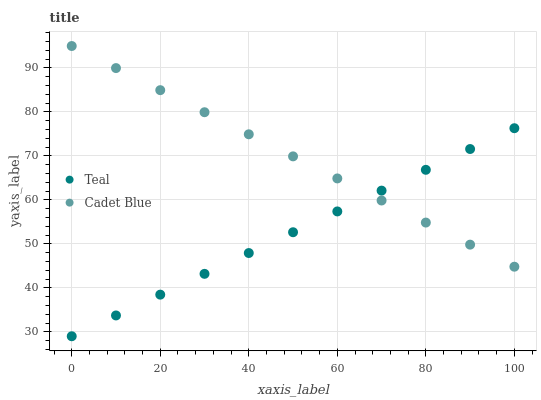Does Teal have the minimum area under the curve?
Answer yes or no. Yes. Does Cadet Blue have the maximum area under the curve?
Answer yes or no. Yes. Does Teal have the maximum area under the curve?
Answer yes or no. No. Is Teal the smoothest?
Answer yes or no. Yes. Is Cadet Blue the roughest?
Answer yes or no. Yes. Is Teal the roughest?
Answer yes or no. No. Does Teal have the lowest value?
Answer yes or no. Yes. Does Cadet Blue have the highest value?
Answer yes or no. Yes. Does Teal have the highest value?
Answer yes or no. No. Does Teal intersect Cadet Blue?
Answer yes or no. Yes. Is Teal less than Cadet Blue?
Answer yes or no. No. Is Teal greater than Cadet Blue?
Answer yes or no. No. 